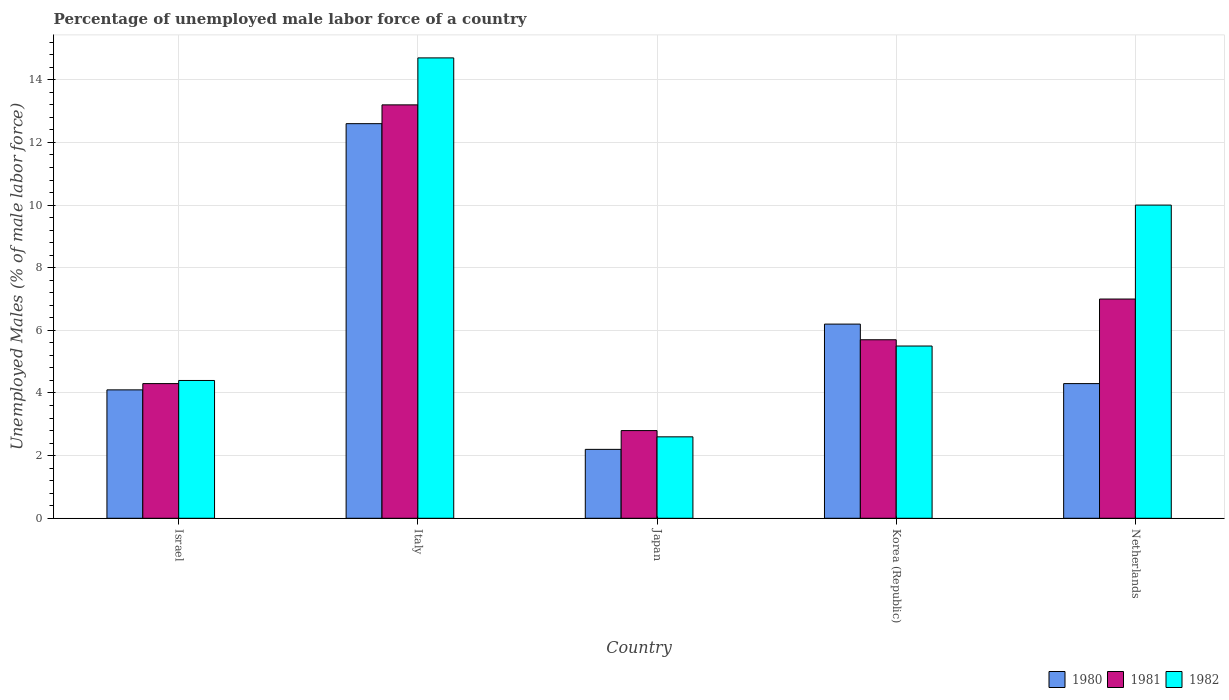How many bars are there on the 5th tick from the left?
Your response must be concise. 3. What is the label of the 4th group of bars from the left?
Offer a very short reply. Korea (Republic). In how many cases, is the number of bars for a given country not equal to the number of legend labels?
Make the answer very short. 0. What is the percentage of unemployed male labor force in 1981 in Korea (Republic)?
Your answer should be compact. 5.7. Across all countries, what is the maximum percentage of unemployed male labor force in 1982?
Provide a succinct answer. 14.7. Across all countries, what is the minimum percentage of unemployed male labor force in 1981?
Your response must be concise. 2.8. What is the total percentage of unemployed male labor force in 1980 in the graph?
Make the answer very short. 29.4. What is the difference between the percentage of unemployed male labor force in 1981 in Japan and that in Korea (Republic)?
Offer a terse response. -2.9. What is the difference between the percentage of unemployed male labor force in 1981 in Israel and the percentage of unemployed male labor force in 1982 in Korea (Republic)?
Give a very brief answer. -1.2. What is the average percentage of unemployed male labor force in 1981 per country?
Offer a very short reply. 6.6. What is the difference between the percentage of unemployed male labor force of/in 1981 and percentage of unemployed male labor force of/in 1980 in Italy?
Your answer should be very brief. 0.6. What is the ratio of the percentage of unemployed male labor force in 1982 in Japan to that in Korea (Republic)?
Your answer should be compact. 0.47. What is the difference between the highest and the lowest percentage of unemployed male labor force in 1982?
Give a very brief answer. 12.1. Is the sum of the percentage of unemployed male labor force in 1982 in Italy and Japan greater than the maximum percentage of unemployed male labor force in 1980 across all countries?
Give a very brief answer. Yes. What does the 3rd bar from the right in Italy represents?
Your answer should be very brief. 1980. Is it the case that in every country, the sum of the percentage of unemployed male labor force in 1981 and percentage of unemployed male labor force in 1982 is greater than the percentage of unemployed male labor force in 1980?
Your answer should be compact. Yes. What is the difference between two consecutive major ticks on the Y-axis?
Provide a succinct answer. 2. Does the graph contain any zero values?
Give a very brief answer. No. Where does the legend appear in the graph?
Ensure brevity in your answer.  Bottom right. How many legend labels are there?
Your answer should be very brief. 3. What is the title of the graph?
Ensure brevity in your answer.  Percentage of unemployed male labor force of a country. What is the label or title of the X-axis?
Make the answer very short. Country. What is the label or title of the Y-axis?
Make the answer very short. Unemployed Males (% of male labor force). What is the Unemployed Males (% of male labor force) in 1980 in Israel?
Give a very brief answer. 4.1. What is the Unemployed Males (% of male labor force) in 1981 in Israel?
Your answer should be very brief. 4.3. What is the Unemployed Males (% of male labor force) of 1982 in Israel?
Your answer should be very brief. 4.4. What is the Unemployed Males (% of male labor force) of 1980 in Italy?
Offer a terse response. 12.6. What is the Unemployed Males (% of male labor force) in 1981 in Italy?
Make the answer very short. 13.2. What is the Unemployed Males (% of male labor force) of 1982 in Italy?
Provide a short and direct response. 14.7. What is the Unemployed Males (% of male labor force) in 1980 in Japan?
Make the answer very short. 2.2. What is the Unemployed Males (% of male labor force) of 1981 in Japan?
Make the answer very short. 2.8. What is the Unemployed Males (% of male labor force) of 1982 in Japan?
Give a very brief answer. 2.6. What is the Unemployed Males (% of male labor force) of 1980 in Korea (Republic)?
Make the answer very short. 6.2. What is the Unemployed Males (% of male labor force) of 1981 in Korea (Republic)?
Offer a very short reply. 5.7. What is the Unemployed Males (% of male labor force) of 1982 in Korea (Republic)?
Offer a terse response. 5.5. What is the Unemployed Males (% of male labor force) of 1980 in Netherlands?
Provide a succinct answer. 4.3. What is the Unemployed Males (% of male labor force) in 1981 in Netherlands?
Provide a short and direct response. 7. Across all countries, what is the maximum Unemployed Males (% of male labor force) of 1980?
Keep it short and to the point. 12.6. Across all countries, what is the maximum Unemployed Males (% of male labor force) in 1981?
Offer a terse response. 13.2. Across all countries, what is the maximum Unemployed Males (% of male labor force) of 1982?
Offer a very short reply. 14.7. Across all countries, what is the minimum Unemployed Males (% of male labor force) in 1980?
Your answer should be very brief. 2.2. Across all countries, what is the minimum Unemployed Males (% of male labor force) of 1981?
Your answer should be very brief. 2.8. Across all countries, what is the minimum Unemployed Males (% of male labor force) of 1982?
Your response must be concise. 2.6. What is the total Unemployed Males (% of male labor force) of 1980 in the graph?
Provide a succinct answer. 29.4. What is the total Unemployed Males (% of male labor force) in 1982 in the graph?
Offer a terse response. 37.2. What is the difference between the Unemployed Males (% of male labor force) of 1980 in Israel and that in Italy?
Ensure brevity in your answer.  -8.5. What is the difference between the Unemployed Males (% of male labor force) in 1981 in Israel and that in Italy?
Offer a terse response. -8.9. What is the difference between the Unemployed Males (% of male labor force) in 1980 in Israel and that in Japan?
Provide a short and direct response. 1.9. What is the difference between the Unemployed Males (% of male labor force) of 1981 in Israel and that in Japan?
Offer a very short reply. 1.5. What is the difference between the Unemployed Males (% of male labor force) in 1980 in Israel and that in Korea (Republic)?
Provide a short and direct response. -2.1. What is the difference between the Unemployed Males (% of male labor force) in 1982 in Israel and that in Korea (Republic)?
Your response must be concise. -1.1. What is the difference between the Unemployed Males (% of male labor force) in 1982 in Israel and that in Netherlands?
Make the answer very short. -5.6. What is the difference between the Unemployed Males (% of male labor force) of 1981 in Italy and that in Japan?
Your answer should be very brief. 10.4. What is the difference between the Unemployed Males (% of male labor force) of 1982 in Italy and that in Japan?
Your answer should be very brief. 12.1. What is the difference between the Unemployed Males (% of male labor force) of 1980 in Italy and that in Korea (Republic)?
Offer a terse response. 6.4. What is the difference between the Unemployed Males (% of male labor force) in 1981 in Italy and that in Korea (Republic)?
Provide a short and direct response. 7.5. What is the difference between the Unemployed Males (% of male labor force) of 1980 in Italy and that in Netherlands?
Your response must be concise. 8.3. What is the difference between the Unemployed Males (% of male labor force) in 1982 in Italy and that in Netherlands?
Your response must be concise. 4.7. What is the difference between the Unemployed Males (% of male labor force) of 1980 in Japan and that in Korea (Republic)?
Make the answer very short. -4. What is the difference between the Unemployed Males (% of male labor force) of 1980 in Japan and that in Netherlands?
Your answer should be very brief. -2.1. What is the difference between the Unemployed Males (% of male labor force) of 1981 in Japan and that in Netherlands?
Provide a succinct answer. -4.2. What is the difference between the Unemployed Males (% of male labor force) of 1980 in Korea (Republic) and that in Netherlands?
Your answer should be compact. 1.9. What is the difference between the Unemployed Males (% of male labor force) in 1981 in Korea (Republic) and that in Netherlands?
Offer a very short reply. -1.3. What is the difference between the Unemployed Males (% of male labor force) of 1981 in Israel and the Unemployed Males (% of male labor force) of 1982 in Japan?
Your answer should be compact. 1.7. What is the difference between the Unemployed Males (% of male labor force) of 1980 in Israel and the Unemployed Males (% of male labor force) of 1981 in Korea (Republic)?
Your response must be concise. -1.6. What is the difference between the Unemployed Males (% of male labor force) in 1980 in Israel and the Unemployed Males (% of male labor force) in 1981 in Netherlands?
Provide a short and direct response. -2.9. What is the difference between the Unemployed Males (% of male labor force) of 1980 in Italy and the Unemployed Males (% of male labor force) of 1981 in Korea (Republic)?
Your answer should be very brief. 6.9. What is the difference between the Unemployed Males (% of male labor force) of 1980 in Italy and the Unemployed Males (% of male labor force) of 1982 in Korea (Republic)?
Ensure brevity in your answer.  7.1. What is the difference between the Unemployed Males (% of male labor force) in 1981 in Italy and the Unemployed Males (% of male labor force) in 1982 in Korea (Republic)?
Offer a terse response. 7.7. What is the difference between the Unemployed Males (% of male labor force) in 1980 in Italy and the Unemployed Males (% of male labor force) in 1981 in Netherlands?
Provide a succinct answer. 5.6. What is the difference between the Unemployed Males (% of male labor force) of 1980 in Japan and the Unemployed Males (% of male labor force) of 1981 in Korea (Republic)?
Your answer should be compact. -3.5. What is the difference between the Unemployed Males (% of male labor force) of 1980 in Japan and the Unemployed Males (% of male labor force) of 1982 in Korea (Republic)?
Offer a very short reply. -3.3. What is the difference between the Unemployed Males (% of male labor force) of 1980 in Japan and the Unemployed Males (% of male labor force) of 1982 in Netherlands?
Provide a succinct answer. -7.8. What is the difference between the Unemployed Males (% of male labor force) of 1980 in Korea (Republic) and the Unemployed Males (% of male labor force) of 1981 in Netherlands?
Provide a short and direct response. -0.8. What is the difference between the Unemployed Males (% of male labor force) of 1980 in Korea (Republic) and the Unemployed Males (% of male labor force) of 1982 in Netherlands?
Ensure brevity in your answer.  -3.8. What is the average Unemployed Males (% of male labor force) of 1980 per country?
Offer a very short reply. 5.88. What is the average Unemployed Males (% of male labor force) in 1982 per country?
Provide a short and direct response. 7.44. What is the difference between the Unemployed Males (% of male labor force) in 1980 and Unemployed Males (% of male labor force) in 1982 in Israel?
Provide a short and direct response. -0.3. What is the difference between the Unemployed Males (% of male labor force) in 1980 and Unemployed Males (% of male labor force) in 1981 in Italy?
Provide a succinct answer. -0.6. What is the difference between the Unemployed Males (% of male labor force) of 1980 and Unemployed Males (% of male labor force) of 1981 in Japan?
Your answer should be compact. -0.6. What is the difference between the Unemployed Males (% of male labor force) of 1980 and Unemployed Males (% of male labor force) of 1982 in Netherlands?
Give a very brief answer. -5.7. What is the difference between the Unemployed Males (% of male labor force) of 1981 and Unemployed Males (% of male labor force) of 1982 in Netherlands?
Your response must be concise. -3. What is the ratio of the Unemployed Males (% of male labor force) of 1980 in Israel to that in Italy?
Ensure brevity in your answer.  0.33. What is the ratio of the Unemployed Males (% of male labor force) in 1981 in Israel to that in Italy?
Your answer should be very brief. 0.33. What is the ratio of the Unemployed Males (% of male labor force) in 1982 in Israel to that in Italy?
Give a very brief answer. 0.3. What is the ratio of the Unemployed Males (% of male labor force) of 1980 in Israel to that in Japan?
Your response must be concise. 1.86. What is the ratio of the Unemployed Males (% of male labor force) in 1981 in Israel to that in Japan?
Give a very brief answer. 1.54. What is the ratio of the Unemployed Males (% of male labor force) of 1982 in Israel to that in Japan?
Make the answer very short. 1.69. What is the ratio of the Unemployed Males (% of male labor force) of 1980 in Israel to that in Korea (Republic)?
Give a very brief answer. 0.66. What is the ratio of the Unemployed Males (% of male labor force) in 1981 in Israel to that in Korea (Republic)?
Offer a terse response. 0.75. What is the ratio of the Unemployed Males (% of male labor force) in 1980 in Israel to that in Netherlands?
Provide a succinct answer. 0.95. What is the ratio of the Unemployed Males (% of male labor force) in 1981 in Israel to that in Netherlands?
Make the answer very short. 0.61. What is the ratio of the Unemployed Males (% of male labor force) in 1982 in Israel to that in Netherlands?
Your response must be concise. 0.44. What is the ratio of the Unemployed Males (% of male labor force) of 1980 in Italy to that in Japan?
Ensure brevity in your answer.  5.73. What is the ratio of the Unemployed Males (% of male labor force) in 1981 in Italy to that in Japan?
Give a very brief answer. 4.71. What is the ratio of the Unemployed Males (% of male labor force) in 1982 in Italy to that in Japan?
Provide a succinct answer. 5.65. What is the ratio of the Unemployed Males (% of male labor force) in 1980 in Italy to that in Korea (Republic)?
Your answer should be compact. 2.03. What is the ratio of the Unemployed Males (% of male labor force) of 1981 in Italy to that in Korea (Republic)?
Keep it short and to the point. 2.32. What is the ratio of the Unemployed Males (% of male labor force) in 1982 in Italy to that in Korea (Republic)?
Provide a short and direct response. 2.67. What is the ratio of the Unemployed Males (% of male labor force) in 1980 in Italy to that in Netherlands?
Make the answer very short. 2.93. What is the ratio of the Unemployed Males (% of male labor force) of 1981 in Italy to that in Netherlands?
Keep it short and to the point. 1.89. What is the ratio of the Unemployed Males (% of male labor force) in 1982 in Italy to that in Netherlands?
Provide a succinct answer. 1.47. What is the ratio of the Unemployed Males (% of male labor force) in 1980 in Japan to that in Korea (Republic)?
Offer a terse response. 0.35. What is the ratio of the Unemployed Males (% of male labor force) of 1981 in Japan to that in Korea (Republic)?
Make the answer very short. 0.49. What is the ratio of the Unemployed Males (% of male labor force) of 1982 in Japan to that in Korea (Republic)?
Give a very brief answer. 0.47. What is the ratio of the Unemployed Males (% of male labor force) in 1980 in Japan to that in Netherlands?
Offer a terse response. 0.51. What is the ratio of the Unemployed Males (% of male labor force) of 1982 in Japan to that in Netherlands?
Your answer should be very brief. 0.26. What is the ratio of the Unemployed Males (% of male labor force) in 1980 in Korea (Republic) to that in Netherlands?
Ensure brevity in your answer.  1.44. What is the ratio of the Unemployed Males (% of male labor force) of 1981 in Korea (Republic) to that in Netherlands?
Keep it short and to the point. 0.81. What is the ratio of the Unemployed Males (% of male labor force) in 1982 in Korea (Republic) to that in Netherlands?
Offer a terse response. 0.55. What is the difference between the highest and the second highest Unemployed Males (% of male labor force) in 1981?
Your response must be concise. 6.2. What is the difference between the highest and the lowest Unemployed Males (% of male labor force) in 1982?
Your response must be concise. 12.1. 